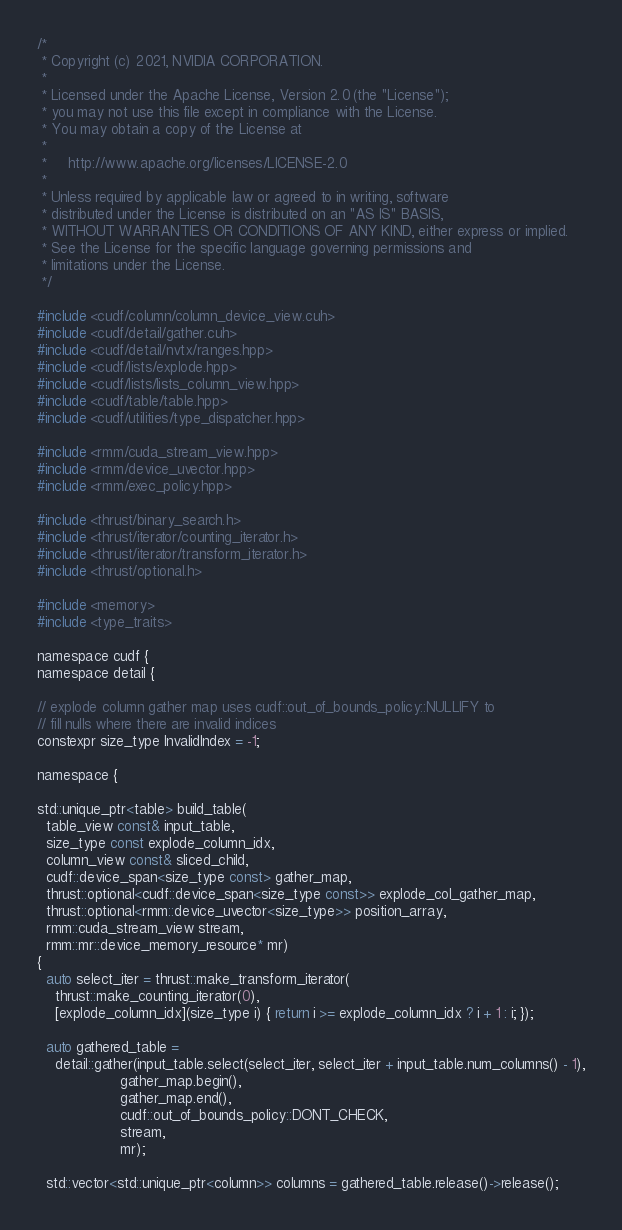<code> <loc_0><loc_0><loc_500><loc_500><_Cuda_>/*
 * Copyright (c) 2021, NVIDIA CORPORATION.
 *
 * Licensed under the Apache License, Version 2.0 (the "License");
 * you may not use this file except in compliance with the License.
 * You may obtain a copy of the License at
 *
 *     http://www.apache.org/licenses/LICENSE-2.0
 *
 * Unless required by applicable law or agreed to in writing, software
 * distributed under the License is distributed on an "AS IS" BASIS,
 * WITHOUT WARRANTIES OR CONDITIONS OF ANY KIND, either express or implied.
 * See the License for the specific language governing permissions and
 * limitations under the License.
 */

#include <cudf/column/column_device_view.cuh>
#include <cudf/detail/gather.cuh>
#include <cudf/detail/nvtx/ranges.hpp>
#include <cudf/lists/explode.hpp>
#include <cudf/lists/lists_column_view.hpp>
#include <cudf/table/table.hpp>
#include <cudf/utilities/type_dispatcher.hpp>

#include <rmm/cuda_stream_view.hpp>
#include <rmm/device_uvector.hpp>
#include <rmm/exec_policy.hpp>

#include <thrust/binary_search.h>
#include <thrust/iterator/counting_iterator.h>
#include <thrust/iterator/transform_iterator.h>
#include <thrust/optional.h>

#include <memory>
#include <type_traits>

namespace cudf {
namespace detail {

// explode column gather map uses cudf::out_of_bounds_policy::NULLIFY to
// fill nulls where there are invalid indices
constexpr size_type InvalidIndex = -1;

namespace {

std::unique_ptr<table> build_table(
  table_view const& input_table,
  size_type const explode_column_idx,
  column_view const& sliced_child,
  cudf::device_span<size_type const> gather_map,
  thrust::optional<cudf::device_span<size_type const>> explode_col_gather_map,
  thrust::optional<rmm::device_uvector<size_type>> position_array,
  rmm::cuda_stream_view stream,
  rmm::mr::device_memory_resource* mr)
{
  auto select_iter = thrust::make_transform_iterator(
    thrust::make_counting_iterator(0),
    [explode_column_idx](size_type i) { return i >= explode_column_idx ? i + 1 : i; });

  auto gathered_table =
    detail::gather(input_table.select(select_iter, select_iter + input_table.num_columns() - 1),
                   gather_map.begin(),
                   gather_map.end(),
                   cudf::out_of_bounds_policy::DONT_CHECK,
                   stream,
                   mr);

  std::vector<std::unique_ptr<column>> columns = gathered_table.release()->release();
</code> 